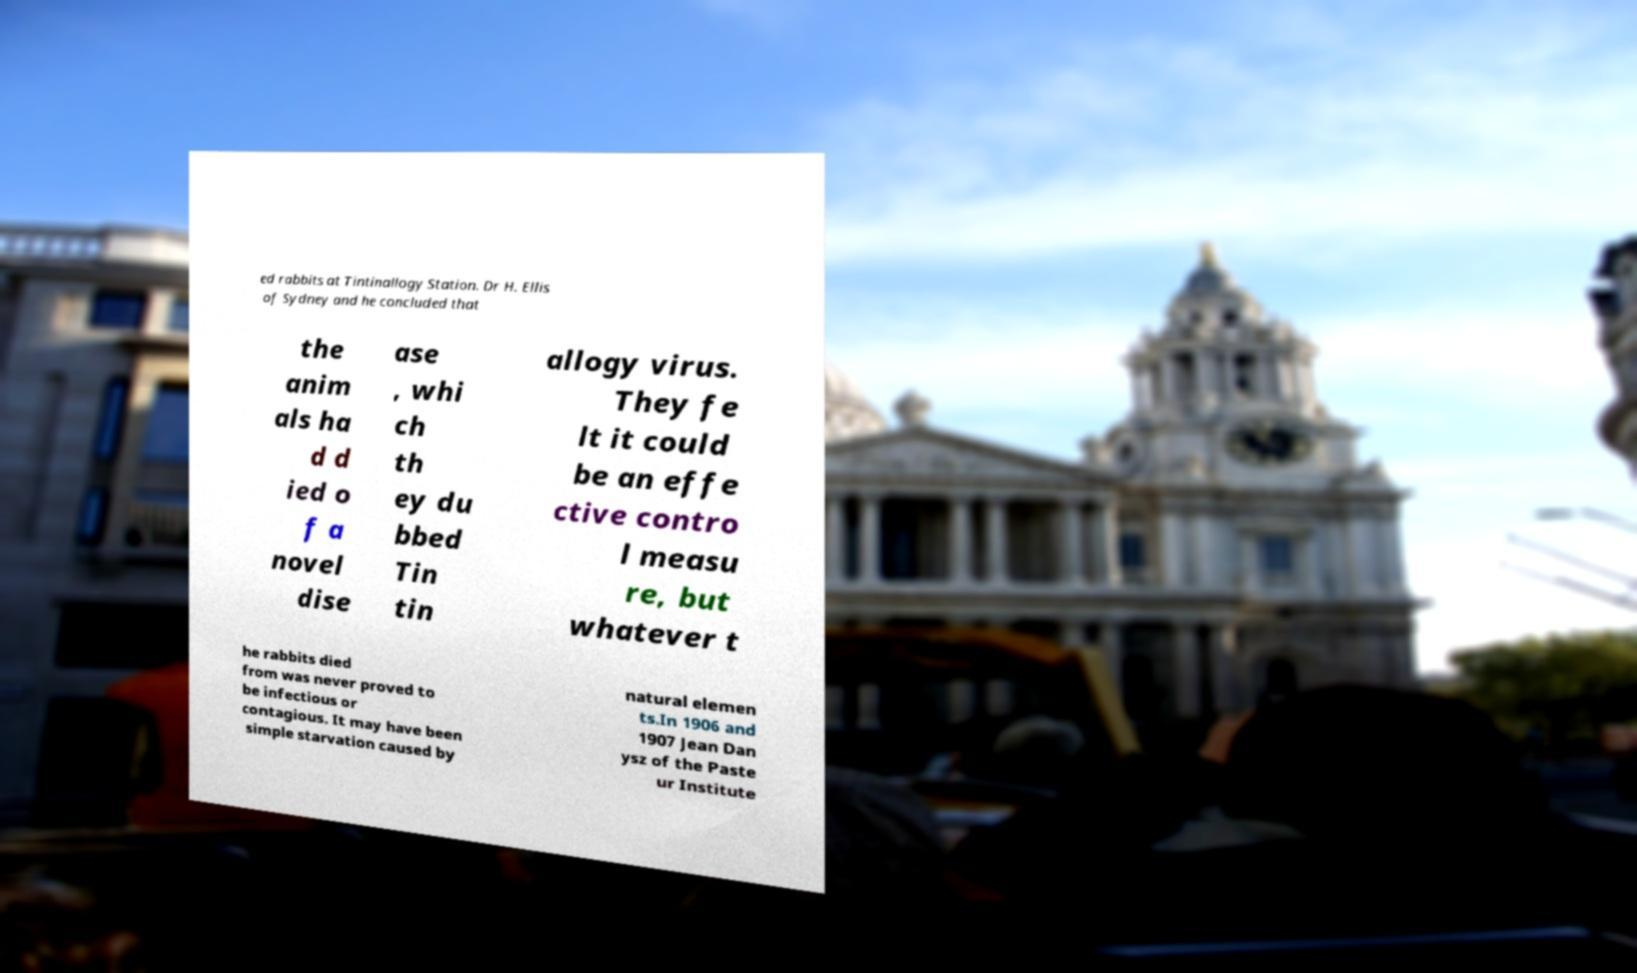Could you extract and type out the text from this image? ed rabbits at Tintinallogy Station. Dr H. Ellis of Sydney and he concluded that the anim als ha d d ied o f a novel dise ase , whi ch th ey du bbed Tin tin allogy virus. They fe lt it could be an effe ctive contro l measu re, but whatever t he rabbits died from was never proved to be infectious or contagious. It may have been simple starvation caused by natural elemen ts.In 1906 and 1907 Jean Dan ysz of the Paste ur Institute 